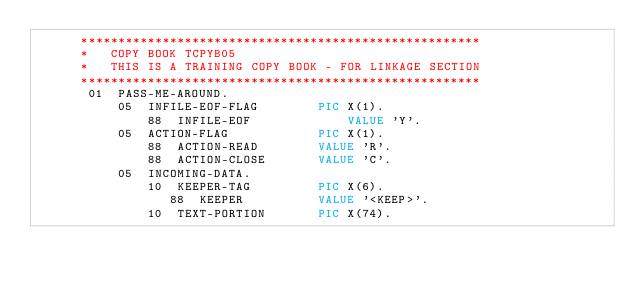Convert code to text. <code><loc_0><loc_0><loc_500><loc_500><_COBOL_>      ******************************************************
      *   COPY BOOK TCPYB05
      *   THIS IS A TRAINING COPY BOOK - FOR LINKAGE SECTION
      ******************************************************
       01  PASS-ME-AROUND.
           05  INFILE-EOF-FLAG        PIC X(1).
               88  INFILE-EOF             VALUE 'Y'.
           05  ACTION-FLAG            PIC X(1).
               88  ACTION-READ        VALUE 'R'.
               88  ACTION-CLOSE       VALUE 'C'.
           05  INCOMING-DATA.
               10  KEEPER-TAG         PIC X(6).
                  88  KEEPER          VALUE '<KEEP>'.
               10  TEXT-PORTION       PIC X(74).</code> 